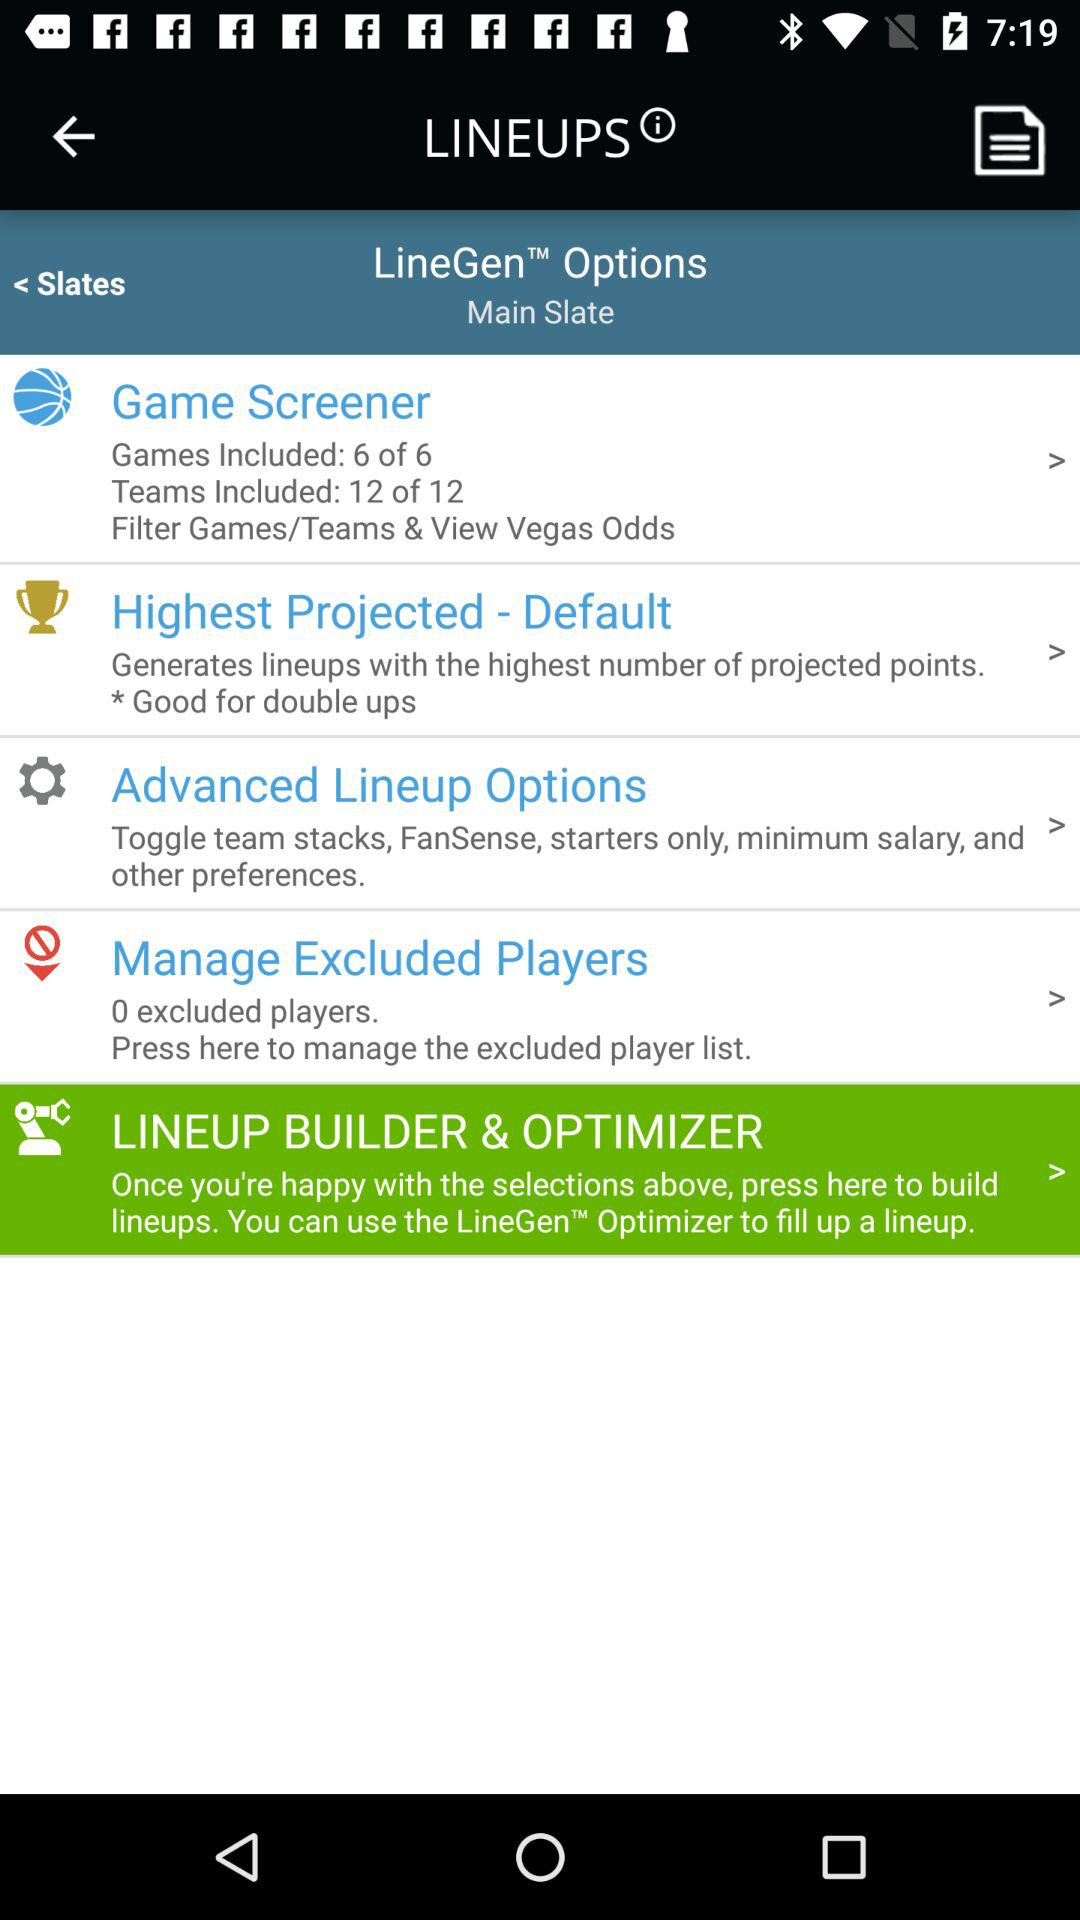What is the number of excluded players? The number of excluded players is 0. 